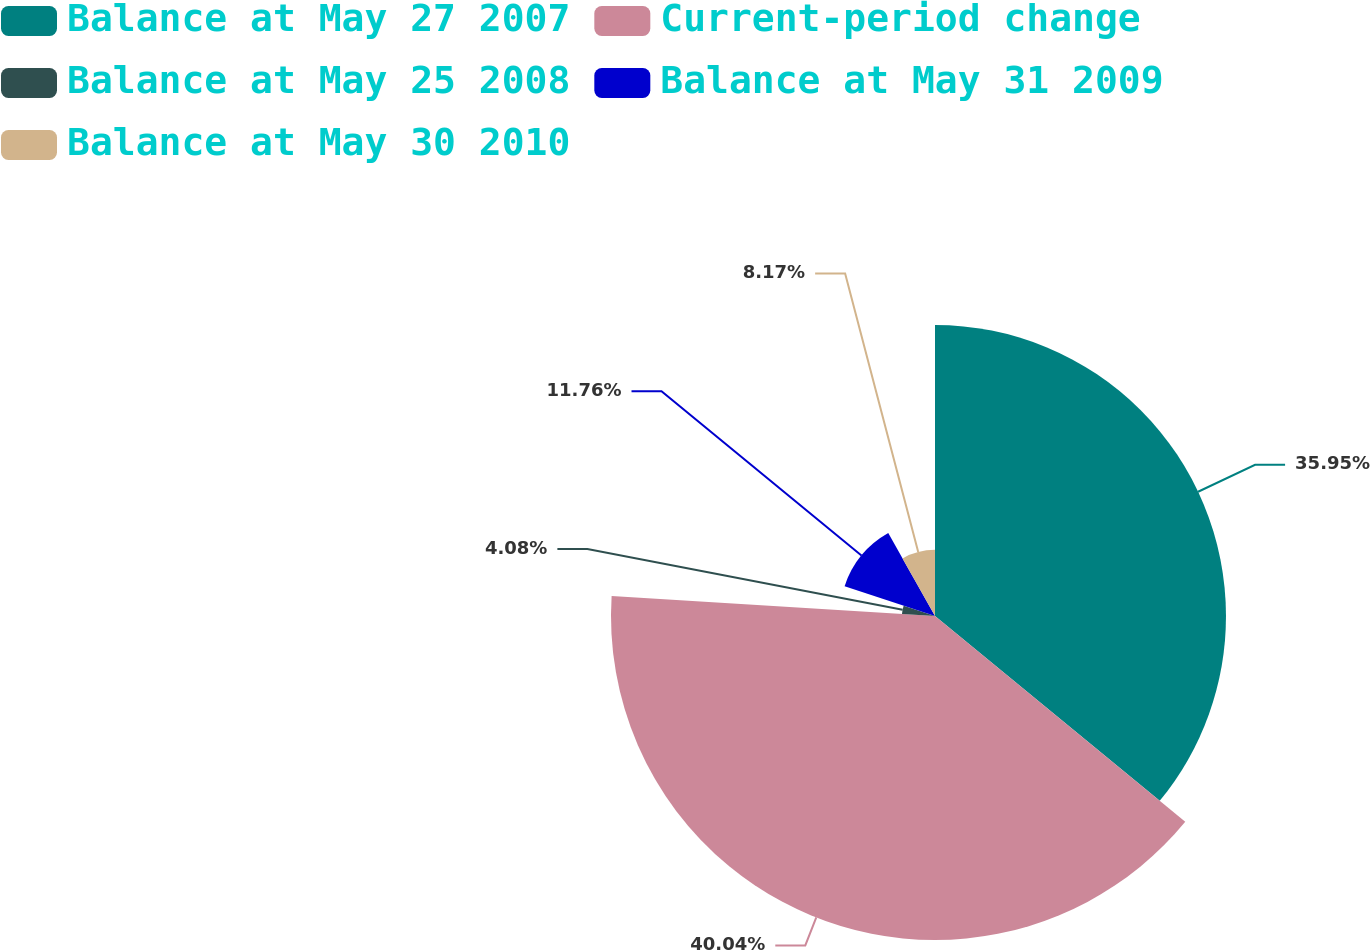<chart> <loc_0><loc_0><loc_500><loc_500><pie_chart><fcel>Balance at May 27 2007<fcel>Current-period change<fcel>Balance at May 25 2008<fcel>Balance at May 31 2009<fcel>Balance at May 30 2010<nl><fcel>35.95%<fcel>40.03%<fcel>4.08%<fcel>11.76%<fcel>8.17%<nl></chart> 